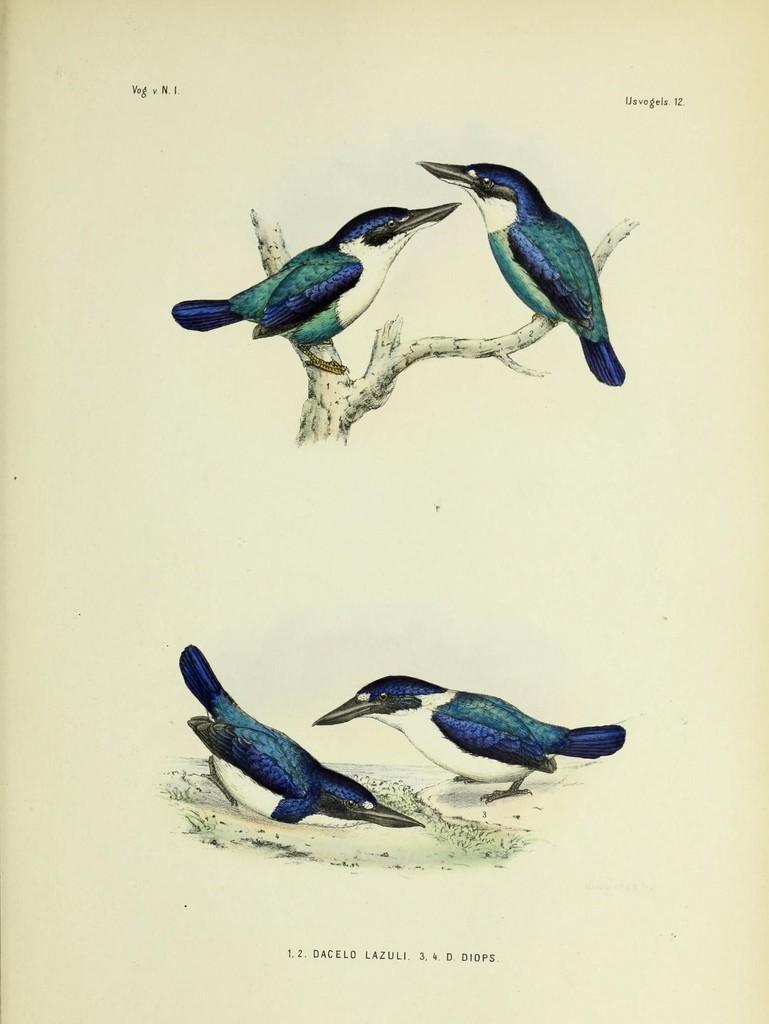What type of animals can be seen in the image? There are birds depicted in the image. What is the birds' environment in the image? The birds are depicted on tree branches in the image. Is there any text or writing visible in the image? Yes, there is text or writing visible in the image. What type of plantation can be seen in the image? There is no plantation depicted in the image; it features birds on tree branches and text or writing. How are the birds connected to the text or writing in the image? The birds and text or writing are separate elements in the image and are not connected. 